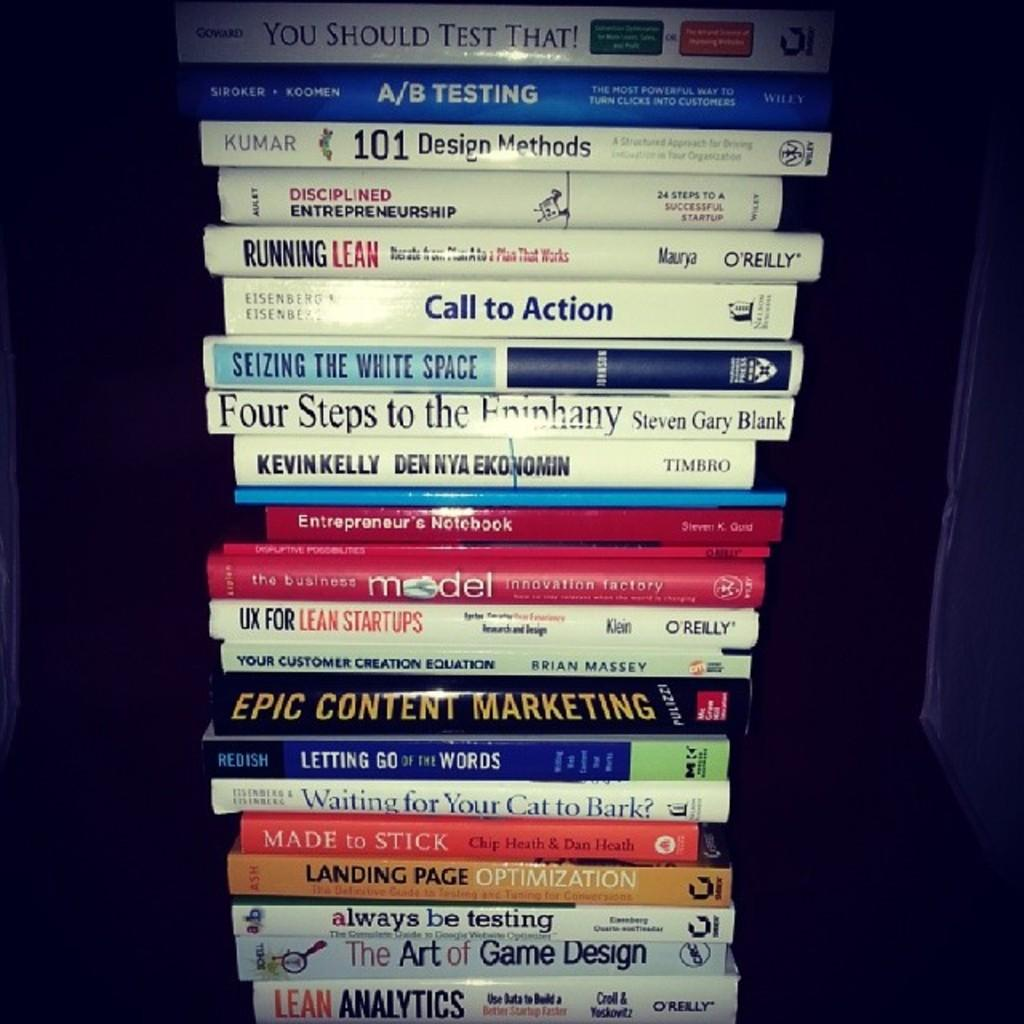<image>
Summarize the visual content of the image. A large stack of books includes titles such as Running Lean, Seizing the White Space, and Epic Content Marketing. 